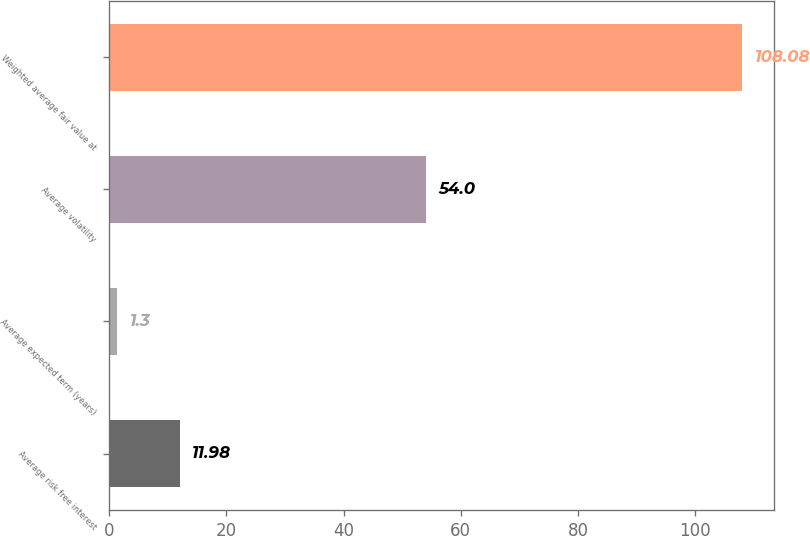<chart> <loc_0><loc_0><loc_500><loc_500><bar_chart><fcel>Average risk free interest<fcel>Average expected term (years)<fcel>Average volatility<fcel>Weighted average fair value at<nl><fcel>11.98<fcel>1.3<fcel>54<fcel>108.08<nl></chart> 